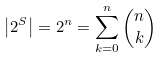Convert formula to latex. <formula><loc_0><loc_0><loc_500><loc_500>\left | 2 ^ { S } \right | = 2 ^ { n } = \sum _ { k = 0 } ^ { n } { \binom { n } { k } }</formula> 